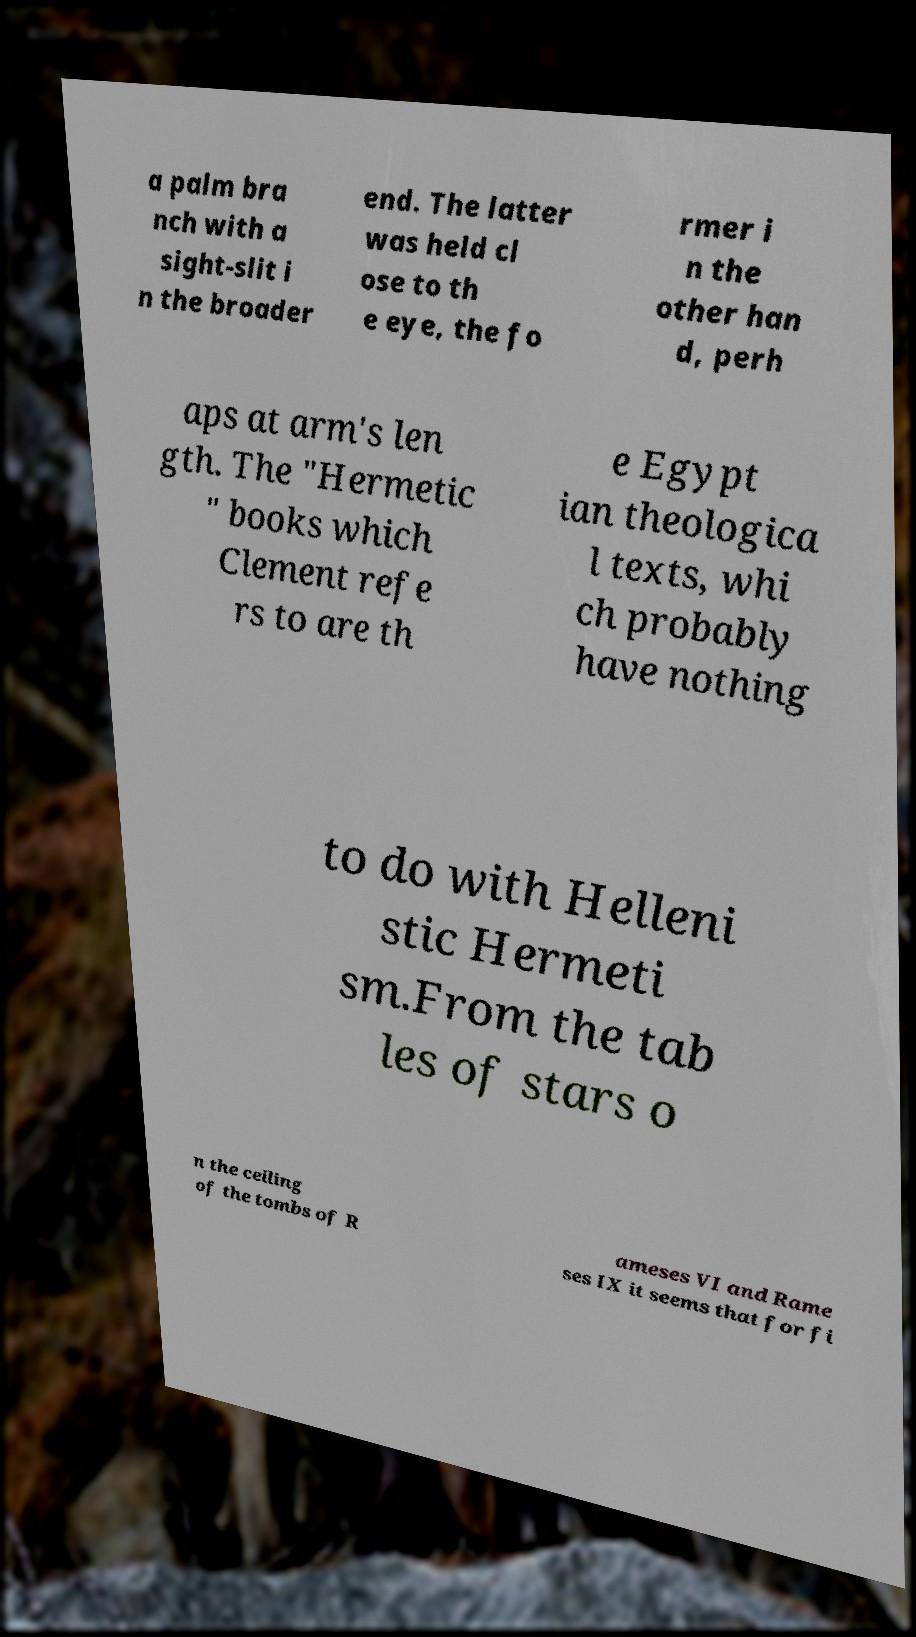For documentation purposes, I need the text within this image transcribed. Could you provide that? a palm bra nch with a sight-slit i n the broader end. The latter was held cl ose to th e eye, the fo rmer i n the other han d, perh aps at arm's len gth. The "Hermetic " books which Clement refe rs to are th e Egypt ian theologica l texts, whi ch probably have nothing to do with Helleni stic Hermeti sm.From the tab les of stars o n the ceiling of the tombs of R ameses VI and Rame ses IX it seems that for fi 